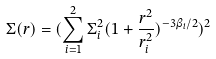<formula> <loc_0><loc_0><loc_500><loc_500>\Sigma ( r ) = ( \sum _ { i = 1 } ^ { 2 } \Sigma _ { i } ^ { 2 } ( 1 + \frac { r ^ { 2 } } { r ^ { 2 } _ { i } } ) ^ { - 3 \beta _ { i } / 2 } ) ^ { 2 }</formula> 